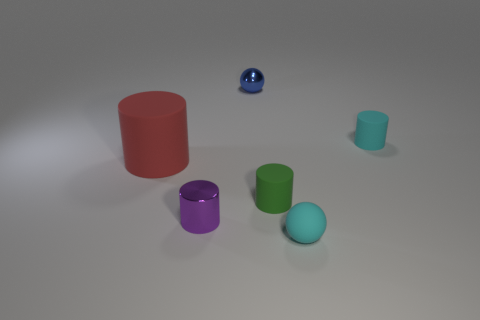Subtract all red cylinders. How many cylinders are left? 3 Subtract 1 cylinders. How many cylinders are left? 3 Subtract all cyan cylinders. How many cylinders are left? 3 Add 1 large red objects. How many objects exist? 7 Subtract all cylinders. How many objects are left? 2 Add 3 shiny cylinders. How many shiny cylinders are left? 4 Add 1 tiny rubber balls. How many tiny rubber balls exist? 2 Subtract 1 cyan balls. How many objects are left? 5 Subtract all green balls. Subtract all red cubes. How many balls are left? 2 Subtract all blue objects. Subtract all green cylinders. How many objects are left? 4 